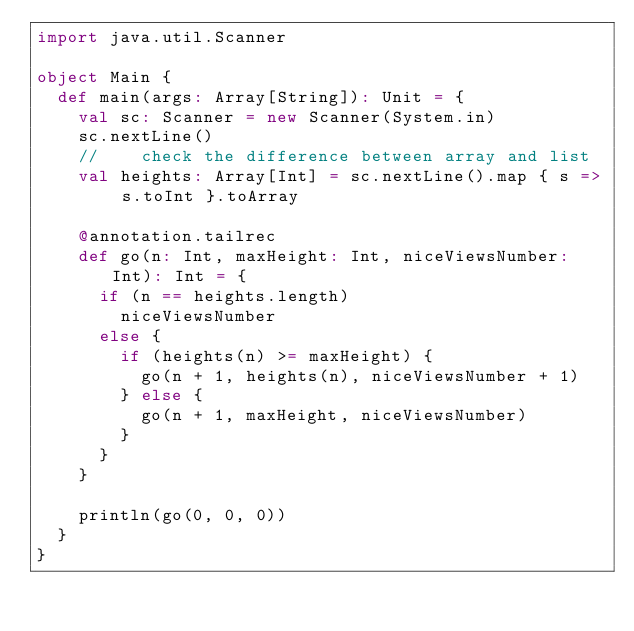<code> <loc_0><loc_0><loc_500><loc_500><_Scala_>import java.util.Scanner

object Main {
  def main(args: Array[String]): Unit = {
    val sc: Scanner = new Scanner(System.in)
    sc.nextLine()
    //    check the difference between array and list
    val heights: Array[Int] = sc.nextLine().map { s => s.toInt }.toArray

    @annotation.tailrec
    def go(n: Int, maxHeight: Int, niceViewsNumber: Int): Int = {
      if (n == heights.length)
        niceViewsNumber
      else {
        if (heights(n) >= maxHeight) {
          go(n + 1, heights(n), niceViewsNumber + 1)
        } else {
          go(n + 1, maxHeight, niceViewsNumber)
        }
      }
    }

    println(go(0, 0, 0))
  }
}</code> 